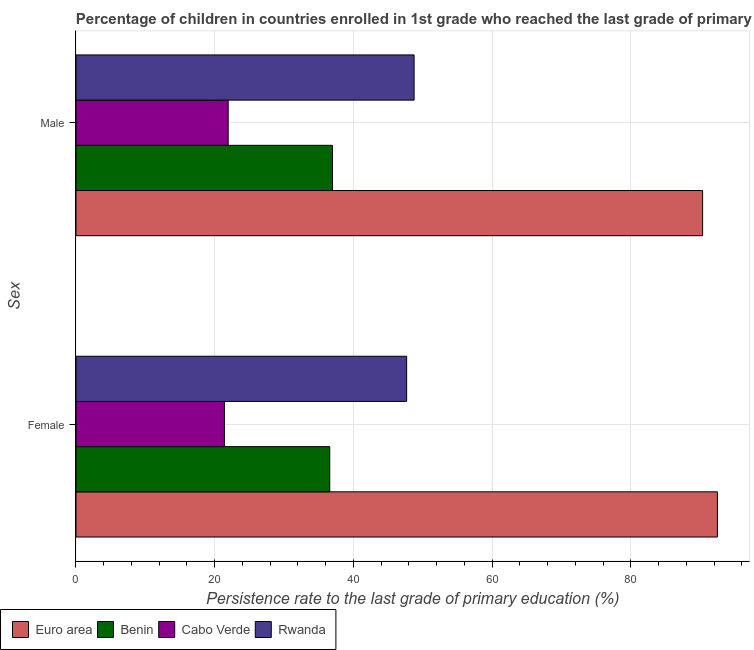How many groups of bars are there?
Provide a succinct answer. 2. How many bars are there on the 1st tick from the top?
Keep it short and to the point. 4. How many bars are there on the 2nd tick from the bottom?
Ensure brevity in your answer.  4. What is the label of the 1st group of bars from the top?
Provide a short and direct response. Male. What is the persistence rate of female students in Euro area?
Provide a short and direct response. 92.48. Across all countries, what is the maximum persistence rate of female students?
Your answer should be very brief. 92.48. Across all countries, what is the minimum persistence rate of male students?
Ensure brevity in your answer.  21.94. In which country was the persistence rate of male students minimum?
Provide a short and direct response. Cabo Verde. What is the total persistence rate of female students in the graph?
Offer a very short reply. 198.14. What is the difference between the persistence rate of male students in Benin and that in Cabo Verde?
Make the answer very short. 15.04. What is the difference between the persistence rate of male students in Benin and the persistence rate of female students in Cabo Verde?
Provide a short and direct response. 15.58. What is the average persistence rate of male students per country?
Your answer should be compact. 49.5. What is the difference between the persistence rate of female students and persistence rate of male students in Rwanda?
Ensure brevity in your answer.  -1.08. In how many countries, is the persistence rate of female students greater than 88 %?
Your response must be concise. 1. What is the ratio of the persistence rate of male students in Benin to that in Rwanda?
Offer a very short reply. 0.76. Is the persistence rate of male students in Cabo Verde less than that in Rwanda?
Provide a succinct answer. Yes. What does the 4th bar from the top in Male represents?
Make the answer very short. Euro area. What is the difference between two consecutive major ticks on the X-axis?
Keep it short and to the point. 20. Does the graph contain any zero values?
Your answer should be very brief. No. Where does the legend appear in the graph?
Offer a terse response. Bottom left. How many legend labels are there?
Offer a terse response. 4. How are the legend labels stacked?
Provide a short and direct response. Horizontal. What is the title of the graph?
Offer a very short reply. Percentage of children in countries enrolled in 1st grade who reached the last grade of primary education. Does "Ukraine" appear as one of the legend labels in the graph?
Make the answer very short. No. What is the label or title of the X-axis?
Ensure brevity in your answer.  Persistence rate to the last grade of primary education (%). What is the label or title of the Y-axis?
Give a very brief answer. Sex. What is the Persistence rate to the last grade of primary education (%) of Euro area in Female?
Ensure brevity in your answer.  92.48. What is the Persistence rate to the last grade of primary education (%) of Benin in Female?
Give a very brief answer. 36.59. What is the Persistence rate to the last grade of primary education (%) of Cabo Verde in Female?
Keep it short and to the point. 21.4. What is the Persistence rate to the last grade of primary education (%) of Rwanda in Female?
Offer a very short reply. 47.67. What is the Persistence rate to the last grade of primary education (%) in Euro area in Male?
Offer a very short reply. 90.35. What is the Persistence rate to the last grade of primary education (%) of Benin in Male?
Keep it short and to the point. 36.98. What is the Persistence rate to the last grade of primary education (%) in Cabo Verde in Male?
Make the answer very short. 21.94. What is the Persistence rate to the last grade of primary education (%) in Rwanda in Male?
Make the answer very short. 48.75. Across all Sex, what is the maximum Persistence rate to the last grade of primary education (%) in Euro area?
Keep it short and to the point. 92.48. Across all Sex, what is the maximum Persistence rate to the last grade of primary education (%) in Benin?
Your response must be concise. 36.98. Across all Sex, what is the maximum Persistence rate to the last grade of primary education (%) of Cabo Verde?
Ensure brevity in your answer.  21.94. Across all Sex, what is the maximum Persistence rate to the last grade of primary education (%) in Rwanda?
Ensure brevity in your answer.  48.75. Across all Sex, what is the minimum Persistence rate to the last grade of primary education (%) of Euro area?
Make the answer very short. 90.35. Across all Sex, what is the minimum Persistence rate to the last grade of primary education (%) in Benin?
Make the answer very short. 36.59. Across all Sex, what is the minimum Persistence rate to the last grade of primary education (%) in Cabo Verde?
Offer a terse response. 21.4. Across all Sex, what is the minimum Persistence rate to the last grade of primary education (%) of Rwanda?
Your answer should be compact. 47.67. What is the total Persistence rate to the last grade of primary education (%) of Euro area in the graph?
Make the answer very short. 182.83. What is the total Persistence rate to the last grade of primary education (%) of Benin in the graph?
Your response must be concise. 73.57. What is the total Persistence rate to the last grade of primary education (%) of Cabo Verde in the graph?
Provide a succinct answer. 43.34. What is the total Persistence rate to the last grade of primary education (%) of Rwanda in the graph?
Your answer should be very brief. 96.43. What is the difference between the Persistence rate to the last grade of primary education (%) of Euro area in Female and that in Male?
Your response must be concise. 2.14. What is the difference between the Persistence rate to the last grade of primary education (%) in Benin in Female and that in Male?
Make the answer very short. -0.39. What is the difference between the Persistence rate to the last grade of primary education (%) of Cabo Verde in Female and that in Male?
Ensure brevity in your answer.  -0.54. What is the difference between the Persistence rate to the last grade of primary education (%) in Rwanda in Female and that in Male?
Keep it short and to the point. -1.08. What is the difference between the Persistence rate to the last grade of primary education (%) in Euro area in Female and the Persistence rate to the last grade of primary education (%) in Benin in Male?
Provide a short and direct response. 55.51. What is the difference between the Persistence rate to the last grade of primary education (%) in Euro area in Female and the Persistence rate to the last grade of primary education (%) in Cabo Verde in Male?
Ensure brevity in your answer.  70.54. What is the difference between the Persistence rate to the last grade of primary education (%) of Euro area in Female and the Persistence rate to the last grade of primary education (%) of Rwanda in Male?
Make the answer very short. 43.73. What is the difference between the Persistence rate to the last grade of primary education (%) in Benin in Female and the Persistence rate to the last grade of primary education (%) in Cabo Verde in Male?
Give a very brief answer. 14.65. What is the difference between the Persistence rate to the last grade of primary education (%) of Benin in Female and the Persistence rate to the last grade of primary education (%) of Rwanda in Male?
Make the answer very short. -12.16. What is the difference between the Persistence rate to the last grade of primary education (%) of Cabo Verde in Female and the Persistence rate to the last grade of primary education (%) of Rwanda in Male?
Provide a short and direct response. -27.35. What is the average Persistence rate to the last grade of primary education (%) in Euro area per Sex?
Your answer should be very brief. 91.42. What is the average Persistence rate to the last grade of primary education (%) of Benin per Sex?
Offer a very short reply. 36.78. What is the average Persistence rate to the last grade of primary education (%) of Cabo Verde per Sex?
Provide a succinct answer. 21.67. What is the average Persistence rate to the last grade of primary education (%) of Rwanda per Sex?
Offer a terse response. 48.21. What is the difference between the Persistence rate to the last grade of primary education (%) of Euro area and Persistence rate to the last grade of primary education (%) of Benin in Female?
Make the answer very short. 55.9. What is the difference between the Persistence rate to the last grade of primary education (%) of Euro area and Persistence rate to the last grade of primary education (%) of Cabo Verde in Female?
Offer a terse response. 71.08. What is the difference between the Persistence rate to the last grade of primary education (%) in Euro area and Persistence rate to the last grade of primary education (%) in Rwanda in Female?
Provide a succinct answer. 44.81. What is the difference between the Persistence rate to the last grade of primary education (%) in Benin and Persistence rate to the last grade of primary education (%) in Cabo Verde in Female?
Your answer should be compact. 15.19. What is the difference between the Persistence rate to the last grade of primary education (%) of Benin and Persistence rate to the last grade of primary education (%) of Rwanda in Female?
Ensure brevity in your answer.  -11.09. What is the difference between the Persistence rate to the last grade of primary education (%) in Cabo Verde and Persistence rate to the last grade of primary education (%) in Rwanda in Female?
Ensure brevity in your answer.  -26.28. What is the difference between the Persistence rate to the last grade of primary education (%) in Euro area and Persistence rate to the last grade of primary education (%) in Benin in Male?
Your answer should be very brief. 53.37. What is the difference between the Persistence rate to the last grade of primary education (%) in Euro area and Persistence rate to the last grade of primary education (%) in Cabo Verde in Male?
Your answer should be very brief. 68.41. What is the difference between the Persistence rate to the last grade of primary education (%) of Euro area and Persistence rate to the last grade of primary education (%) of Rwanda in Male?
Your answer should be compact. 41.6. What is the difference between the Persistence rate to the last grade of primary education (%) of Benin and Persistence rate to the last grade of primary education (%) of Cabo Verde in Male?
Give a very brief answer. 15.04. What is the difference between the Persistence rate to the last grade of primary education (%) in Benin and Persistence rate to the last grade of primary education (%) in Rwanda in Male?
Your answer should be compact. -11.77. What is the difference between the Persistence rate to the last grade of primary education (%) in Cabo Verde and Persistence rate to the last grade of primary education (%) in Rwanda in Male?
Your answer should be compact. -26.81. What is the ratio of the Persistence rate to the last grade of primary education (%) in Euro area in Female to that in Male?
Your answer should be very brief. 1.02. What is the ratio of the Persistence rate to the last grade of primary education (%) in Benin in Female to that in Male?
Your response must be concise. 0.99. What is the ratio of the Persistence rate to the last grade of primary education (%) in Cabo Verde in Female to that in Male?
Your answer should be compact. 0.98. What is the ratio of the Persistence rate to the last grade of primary education (%) in Rwanda in Female to that in Male?
Provide a short and direct response. 0.98. What is the difference between the highest and the second highest Persistence rate to the last grade of primary education (%) in Euro area?
Offer a terse response. 2.14. What is the difference between the highest and the second highest Persistence rate to the last grade of primary education (%) of Benin?
Offer a very short reply. 0.39. What is the difference between the highest and the second highest Persistence rate to the last grade of primary education (%) of Cabo Verde?
Offer a very short reply. 0.54. What is the difference between the highest and the second highest Persistence rate to the last grade of primary education (%) in Rwanda?
Provide a short and direct response. 1.08. What is the difference between the highest and the lowest Persistence rate to the last grade of primary education (%) of Euro area?
Keep it short and to the point. 2.14. What is the difference between the highest and the lowest Persistence rate to the last grade of primary education (%) of Benin?
Offer a terse response. 0.39. What is the difference between the highest and the lowest Persistence rate to the last grade of primary education (%) of Cabo Verde?
Offer a terse response. 0.54. What is the difference between the highest and the lowest Persistence rate to the last grade of primary education (%) in Rwanda?
Your answer should be very brief. 1.08. 